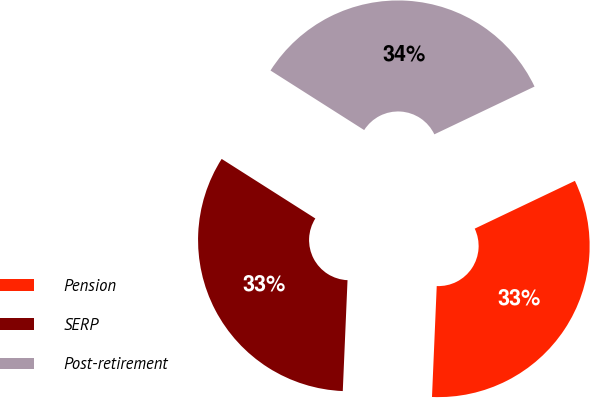Convert chart. <chart><loc_0><loc_0><loc_500><loc_500><pie_chart><fcel>Pension<fcel>SERP<fcel>Post-retirement<nl><fcel>32.76%<fcel>33.33%<fcel>33.9%<nl></chart> 